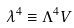<formula> <loc_0><loc_0><loc_500><loc_500>\lambda ^ { 4 } \equiv \Lambda ^ { 4 } V</formula> 